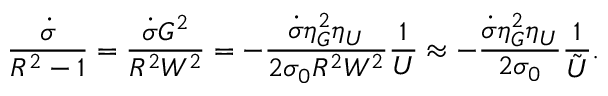Convert formula to latex. <formula><loc_0><loc_0><loc_500><loc_500>\frac { \dot { \sigma } } { R ^ { 2 } - 1 } = \frac { \dot { \sigma } G ^ { 2 } } { R ^ { 2 } W ^ { 2 } } = - \frac { \dot { \sigma } \eta _ { G } ^ { 2 } \eta _ { U } } { 2 \sigma _ { 0 } R ^ { 2 } W ^ { 2 } } \frac { 1 } { U } \approx - \frac { \dot { \sigma } \eta _ { G } ^ { 2 } \eta _ { U } } { 2 \sigma _ { 0 } } \frac { 1 } { \tilde { U } } .</formula> 